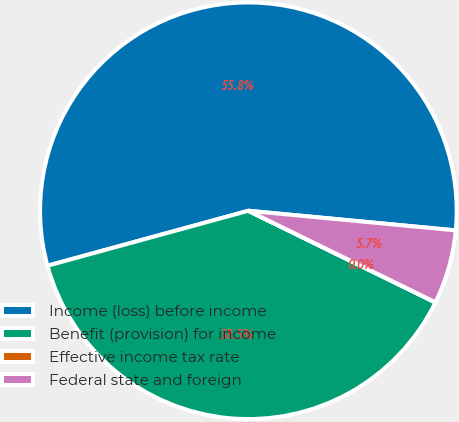<chart> <loc_0><loc_0><loc_500><loc_500><pie_chart><fcel>Income (loss) before income<fcel>Benefit (provision) for income<fcel>Effective income tax rate<fcel>Federal state and foreign<nl><fcel>55.76%<fcel>38.5%<fcel>0.01%<fcel>5.74%<nl></chart> 